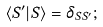Convert formula to latex. <formula><loc_0><loc_0><loc_500><loc_500>\langle S ^ { \prime } | S \rangle = \delta _ { S S ^ { \prime } } ;</formula> 